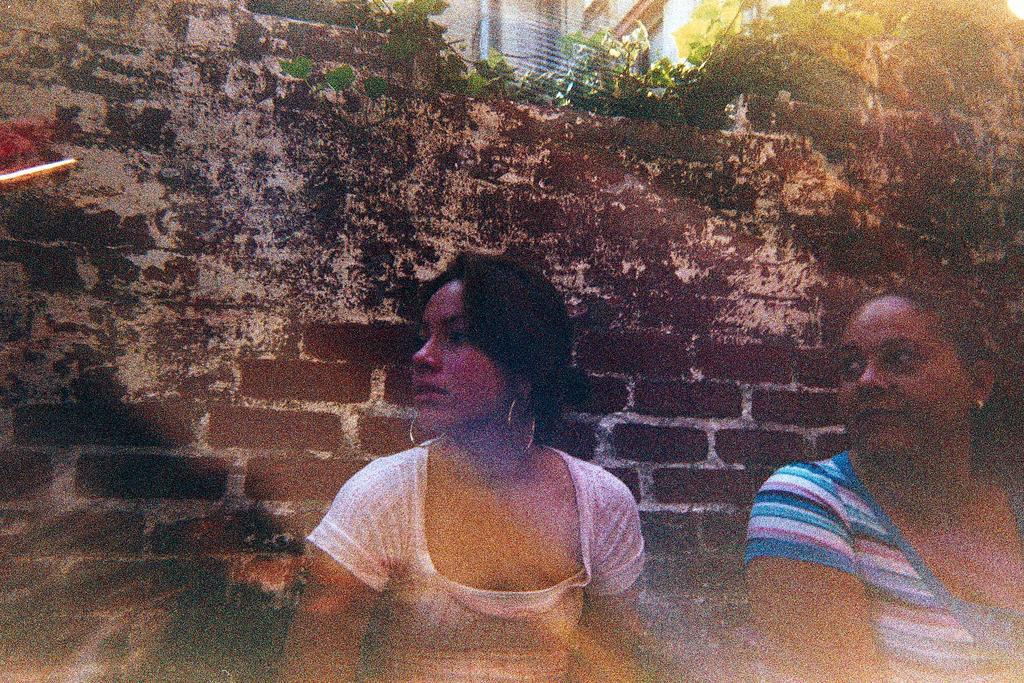Please provide a concise description of this image. This image is an edited image. This image is taken outdoors. In the background there is a wall and there is a creeper with leaves and stems. On the right side of the image there is a woman. In the middle of the image there is a girl. 